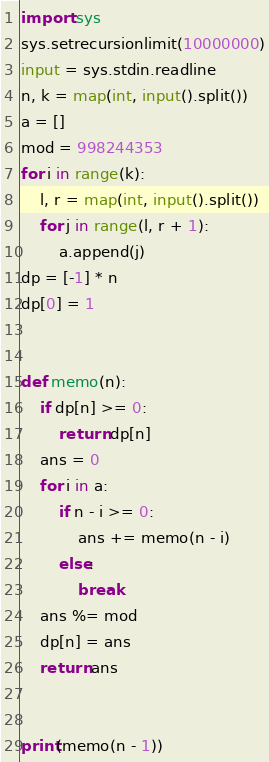<code> <loc_0><loc_0><loc_500><loc_500><_Cython_>import sys
sys.setrecursionlimit(10000000)
input = sys.stdin.readline
n, k = map(int, input().split())
a = []
mod = 998244353
for i in range(k):
    l, r = map(int, input().split())
    for j in range(l, r + 1):
        a.append(j)
dp = [-1] * n
dp[0] = 1


def memo(n):
    if dp[n] >= 0:
        return dp[n]
    ans = 0
    for i in a:
        if n - i >= 0:
            ans += memo(n - i)
        else:
            break
    ans %= mod
    dp[n] = ans
    return ans


print(memo(n - 1))
</code> 